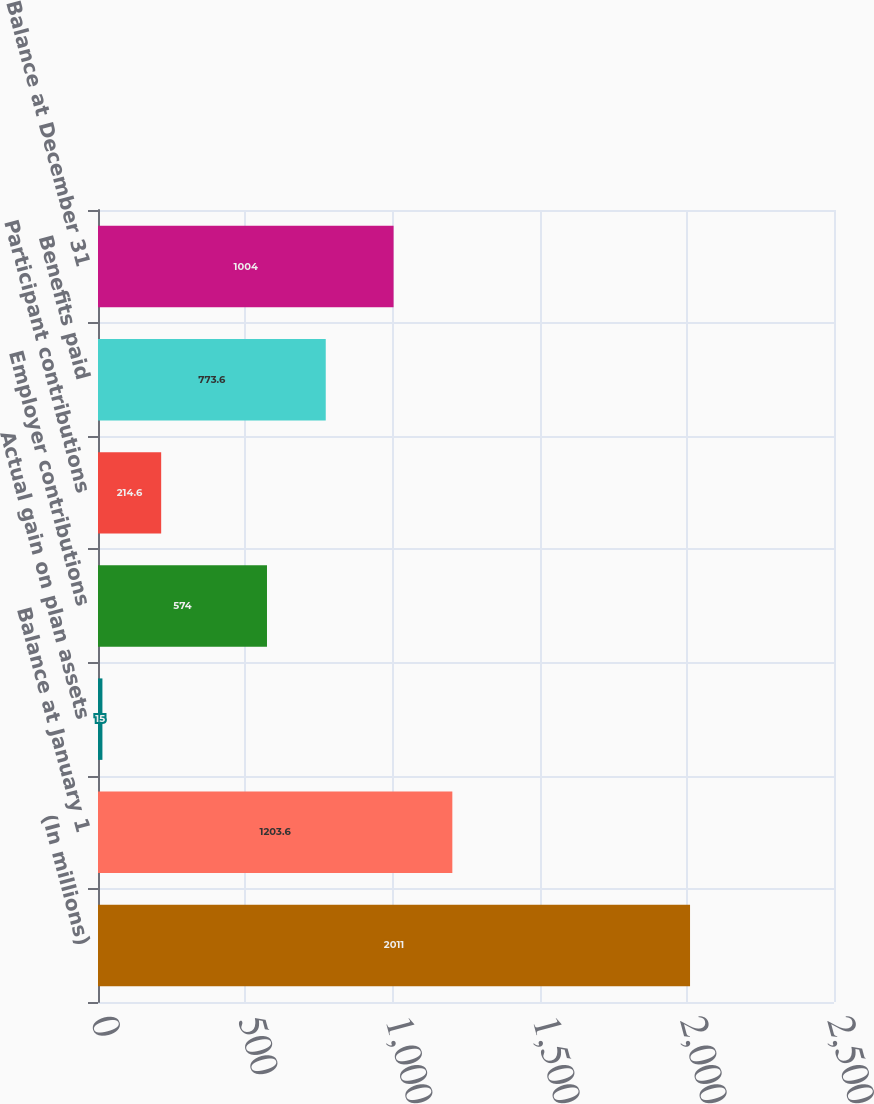Convert chart. <chart><loc_0><loc_0><loc_500><loc_500><bar_chart><fcel>(In millions)<fcel>Balance at January 1<fcel>Actual gain on plan assets<fcel>Employer contributions<fcel>Participant contributions<fcel>Benefits paid<fcel>Balance at December 31<nl><fcel>2011<fcel>1203.6<fcel>15<fcel>574<fcel>214.6<fcel>773.6<fcel>1004<nl></chart> 